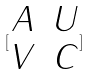<formula> <loc_0><loc_0><loc_500><loc_500>[ \begin{matrix} A & U \\ V & C \end{matrix} ]</formula> 